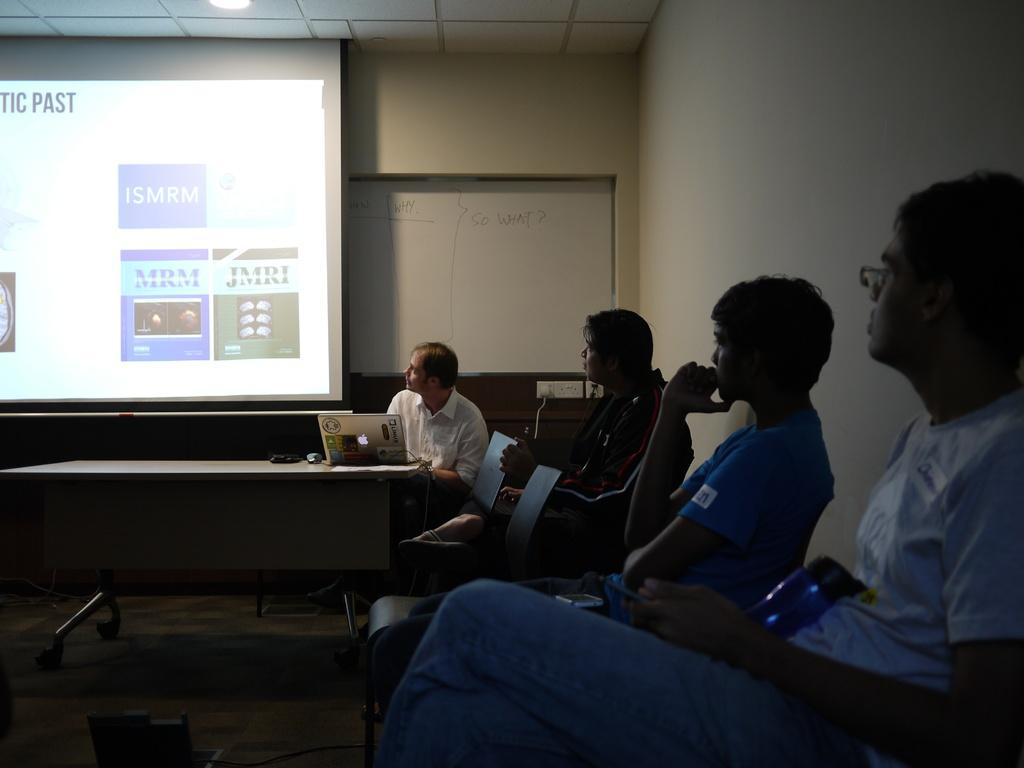What are the people in the image doing? The people in the image are sitting. What is on the table in the image? There are devices on the table in the image. What is being used for displaying information or media in the image? There is a projector screen in the image. What is the board in the image used for? The board in the image is likely used for writing or displaying information. What structures can be seen in the image? There is a wall, a roof, and the ground visible in the image. What type of account is being discussed by the people in the image? There is no indication in the image that the people are discussing any type of account. Can you tell me how much milk is being poured into the cups in the image? There is no milk or cups present in the image. 